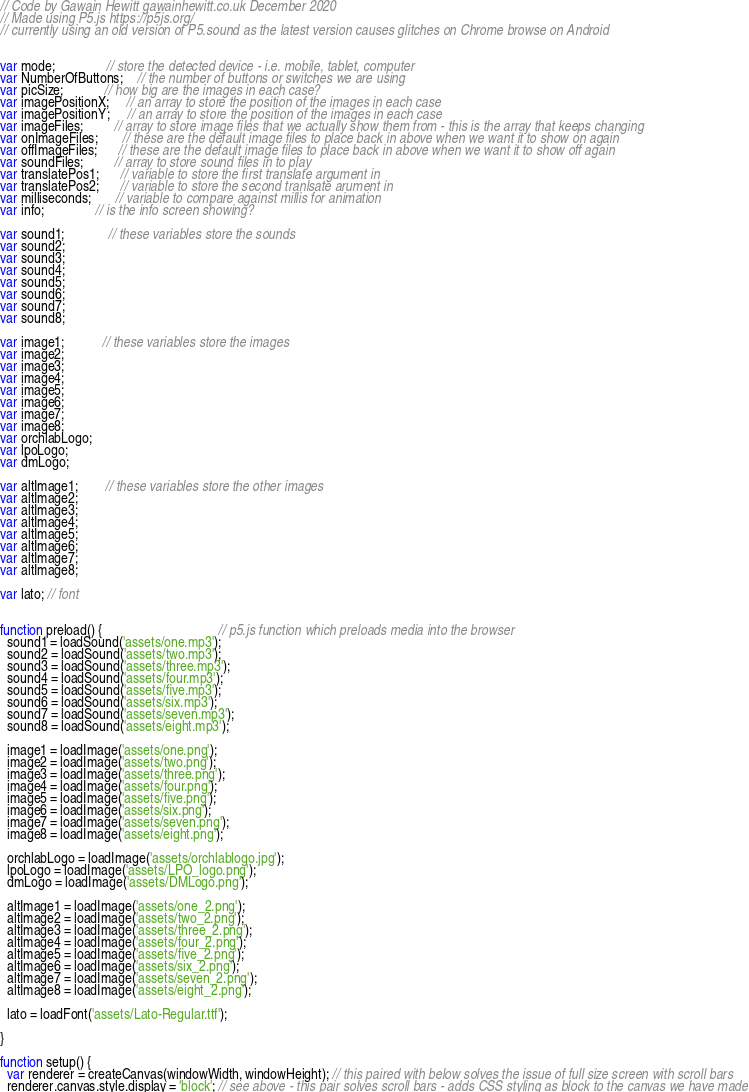<code> <loc_0><loc_0><loc_500><loc_500><_JavaScript_>// Code by Gawain Hewitt gawainhewitt.co.uk December 2020
// Made using P5.js https://p5js.org/
// currently using an old version of P5.sound as the latest version causes glitches on Chrome browse on Android


var mode;               // store the detected device - i.e. mobile, tablet, computer
var NumberOfButtons;    // the number of buttons or switches we are using
var picSize;            // how big are the images in each case?
var imagePositionX;     // an array to store the position of the images in each case
var imagePositionY;     // an array to store the position of the images in each case
var imageFiles;         // array to store image files that we actually show them from - this is the array that keeps changing
var onImageFiles;       // these are the default image files to place back in above when we want it to show on again
var offImageFiles;      // these are the default image files to place back in above when we want it to show off again
var soundFiles;         // array to store sound files in to play
var translatePos1;      // variable to store the first translate argument in
var translatePos2;      // variable to store the second tranlsate arument in
var milliseconds;       // variable to compare against millis for animation
var info;               // is the info screen showing?

var sound1;             // these variables store the sounds
var sound2;
var sound3;
var sound4;
var sound5;
var sound6;
var sound7;
var sound8;

var image1;           // these variables store the images
var image2;
var image3;
var image4;
var image5;
var image6;
var image7;
var image8;
var orchlabLogo;
var lpoLogo;
var dmLogo;

var altImage1;        // these variables store the other images
var altImage2;
var altImage3;
var altImage4;
var altImage5;
var altImage6;
var altImage7;
var altImage8;

var lato; // font


function preload() {                                  // p5.js function which preloads media into the browser
  sound1 = loadSound('assets/one.mp3');
  sound2 = loadSound('assets/two.mp3');
  sound3 = loadSound('assets/three.mp3');
  sound4 = loadSound('assets/four.mp3');
  sound5 = loadSound('assets/five.mp3');
  sound6 = loadSound('assets/six.mp3');
  sound7 = loadSound('assets/seven.mp3');
  sound8 = loadSound('assets/eight.mp3');

  image1 = loadImage('assets/one.png');
  image2 = loadImage('assets/two.png');
  image3 = loadImage('assets/three.png');
  image4 = loadImage('assets/four.png');
  image5 = loadImage('assets/five.png');
  image6 = loadImage('assets/six.png');
  image7 = loadImage('assets/seven.png');
  image8 = loadImage('assets/eight.png');

  orchlabLogo = loadImage('assets/orchlablogo.jpg');
  lpoLogo = loadImage('assets/LPO_logo.png');
  dmLogo = loadImage('assets/DMLogo.png');

  altImage1 = loadImage('assets/one_2.png');
  altImage2 = loadImage('assets/two_2.png');
  altImage3 = loadImage('assets/three_2.png');
  altImage4 = loadImage('assets/four_2.png');
  altImage5 = loadImage('assets/five_2.png');
  altImage6 = loadImage('assets/six_2.png');
  altImage7 = loadImage('assets/seven_2.png');
  altImage8 = loadImage('assets/eight_2.png');

  lato = loadFont('assets/Lato-Regular.ttf');

}

function setup() {
  var renderer = createCanvas(windowWidth, windowHeight); // this paired with below solves the issue of full size screen with scroll bars
  renderer.canvas.style.display = 'block'; // see above - this pair solves scroll bars - adds CSS styling as block to the canvas we have made</code> 